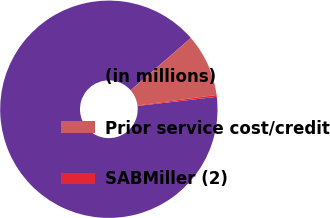Convert chart. <chart><loc_0><loc_0><loc_500><loc_500><pie_chart><fcel>(in millions)<fcel>Prior service cost/credit<fcel>SABMiller (2)<nl><fcel>90.44%<fcel>9.29%<fcel>0.27%<nl></chart> 